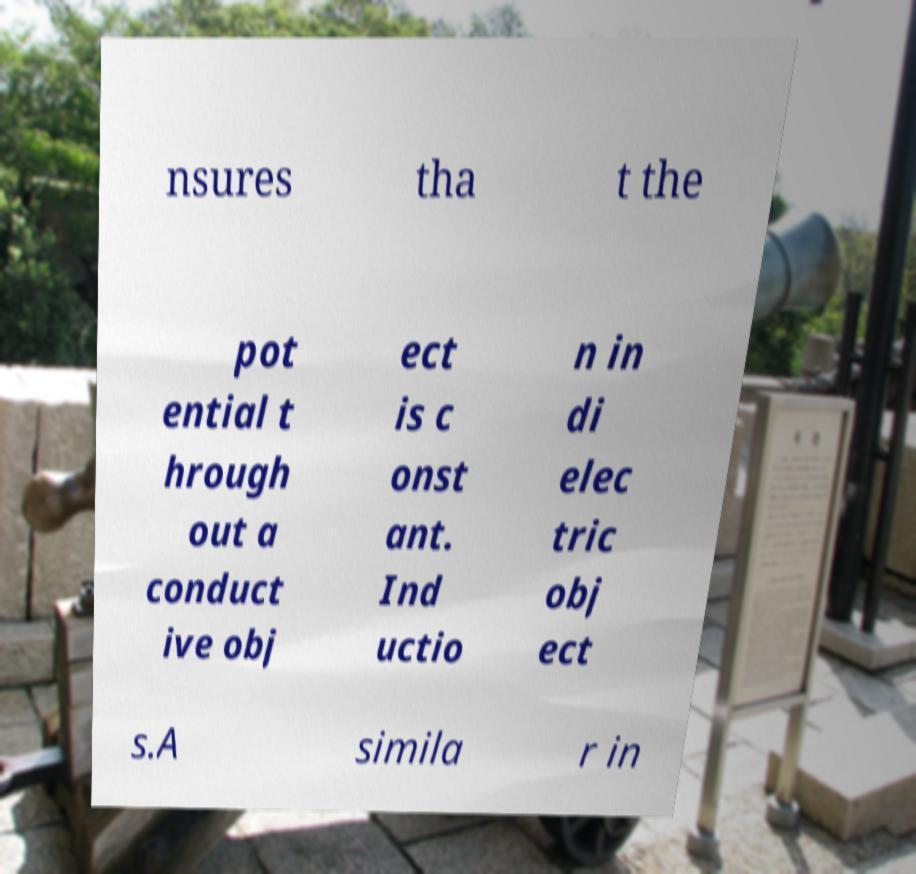There's text embedded in this image that I need extracted. Can you transcribe it verbatim? nsures tha t the pot ential t hrough out a conduct ive obj ect is c onst ant. Ind uctio n in di elec tric obj ect s.A simila r in 